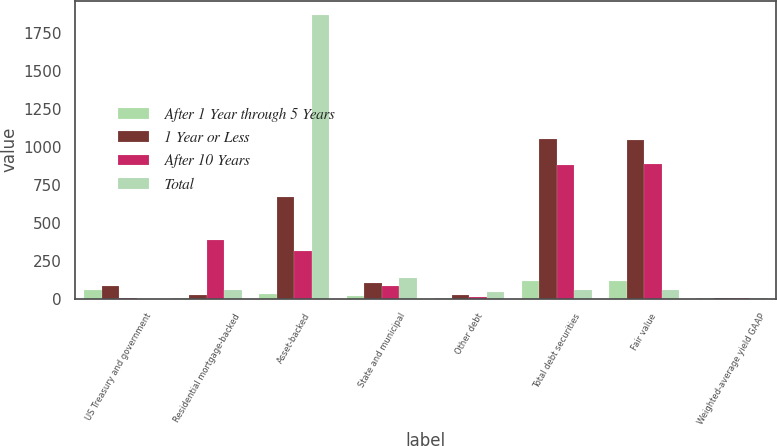<chart> <loc_0><loc_0><loc_500><loc_500><stacked_bar_chart><ecel><fcel>US Treasury and government<fcel>Residential mortgage-backed<fcel>Asset-backed<fcel>State and municipal<fcel>Other debt<fcel>Total debt securities<fcel>Fair value<fcel>Weighted-average yield GAAP<nl><fcel>After 1 Year through 5 Years<fcel>60<fcel>2<fcel>30<fcel>18<fcel>6<fcel>116<fcel>116<fcel>4.66<nl><fcel>1 Year or Less<fcel>85<fcel>24<fcel>669<fcel>100<fcel>21<fcel>1048<fcel>1045<fcel>5.06<nl><fcel>After 10 Years<fcel>5<fcel>386<fcel>312<fcel>83<fcel>13<fcel>876<fcel>883<fcel>5.02<nl><fcel>Total<fcel>1<fcel>60<fcel>1867<fcel>139<fcel>45<fcel>60<fcel>60<fcel>5.43<nl></chart> 